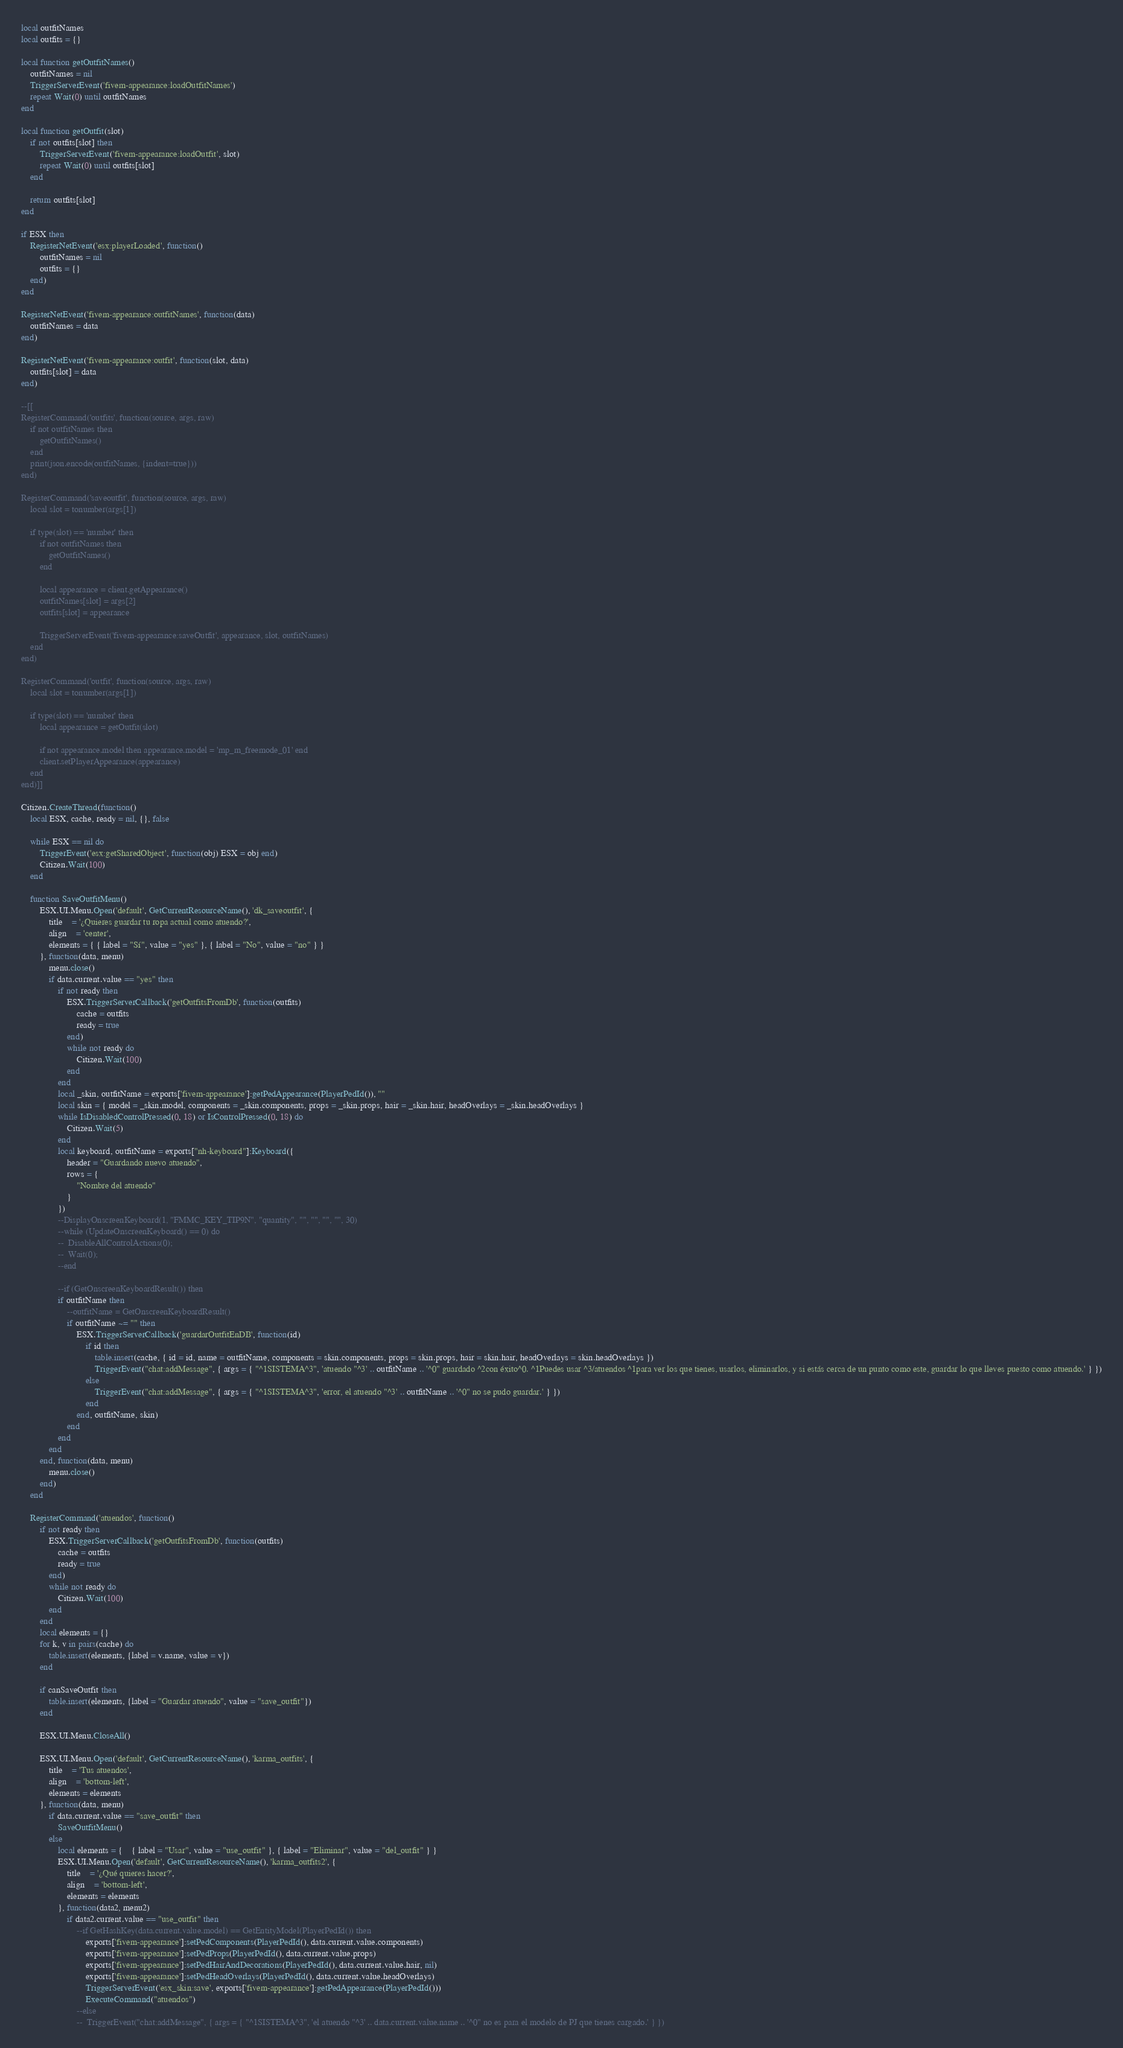<code> <loc_0><loc_0><loc_500><loc_500><_Lua_>
local outfitNames
local outfits = {}

local function getOutfitNames()
	outfitNames = nil
	TriggerServerEvent('fivem-appearance:loadOutfitNames')
	repeat Wait(0) until outfitNames
end

local function getOutfit(slot)
	if not outfits[slot] then
		TriggerServerEvent('fivem-appearance:loadOutfit', slot)
		repeat Wait(0) until outfits[slot]
	end

	return outfits[slot]
end

if ESX then
	RegisterNetEvent('esx:playerLoaded', function()
		outfitNames = nil
		outfits = {}
	end)
end

RegisterNetEvent('fivem-appearance:outfitNames', function(data)
	outfitNames = data
end)

RegisterNetEvent('fivem-appearance:outfit', function(slot, data)
	outfits[slot] = data
end)

--[[
RegisterCommand('outfits', function(source, args, raw)
	if not outfitNames then
		getOutfitNames()
	end
	print(json.encode(outfitNames, {indent=true}))
end)

RegisterCommand('saveoutfit', function(source, args, raw)
	local slot = tonumber(args[1])

	if type(slot) == 'number' then
		if not outfitNames then
			getOutfitNames()
		end

		local appearance = client.getAppearance()
		outfitNames[slot] = args[2]
		outfits[slot] = appearance

		TriggerServerEvent('fivem-appearance:saveOutfit', appearance, slot, outfitNames)
	end
end)

RegisterCommand('outfit', function(source, args, raw)
	local slot = tonumber(args[1])

	if type(slot) == 'number' then
		local appearance = getOutfit(slot)

		if not appearance.model then appearance.model = 'mp_m_freemode_01' end
		client.setPlayerAppearance(appearance)
	end
end)]]

Citizen.CreateThread(function()
	local ESX, cache, ready = nil, {}, false

    while ESX == nil do
        TriggerEvent('esx:getSharedObject', function(obj) ESX = obj end)
        Citizen.Wait(100)
    end

	function SaveOutfitMenu()
		ESX.UI.Menu.Open('default', GetCurrentResourceName(), 'dk_saveoutfit', {
			title    = '¿Quieres guardar tu ropa actual como atuendo?',
			align    = 'center',
			elements = { { label = "Sí", value = "yes" }, { label = "No", value = "no" } }
		}, function(data, menu)
			menu.close()
			if data.current.value == "yes" then
				if not ready then
					ESX.TriggerServerCallback('getOutfitsFromDb', function(outfits)
						cache = outfits
						ready = true
					end)
					while not ready do
						Citizen.Wait(100)
					end
				end
				local _skin, outfitName = exports['fivem-appearance']:getPedAppearance(PlayerPedId()), ""
				local skin = { model = _skin.model, components = _skin.components, props = _skin.props, hair = _skin.hair, headOverlays = _skin.headOverlays }
				while IsDisabledControlPressed(0, 18) or IsControlPressed(0, 18) do
					Citizen.Wait(5)
				end
				local keyboard, outfitName = exports["nh-keyboard"]:Keyboard({
					header = "Guardando nuevo atuendo",
					rows = {
						"Nombre del atuendo"
					}
				})
				--DisplayOnscreenKeyboard(1, "FMMC_KEY_TIP9N", "quantity", "", "", "", "", 30)
				--while (UpdateOnscreenKeyboard() == 0) do
				--	DisableAllControlActions(0);
				--	Wait(0);
				--end
			
				--if (GetOnscreenKeyboardResult()) then
				if outfitName then
					--outfitName = GetOnscreenKeyboardResult()
					if outfitName ~= "" then
						ESX.TriggerServerCallback('guardarOutfitEnDB', function(id)
							if id then
								table.insert(cache, { id = id, name = outfitName, components = skin.components, props = skin.props, hair = skin.hair, headOverlays = skin.headOverlays })
								TriggerEvent("chat:addMessage", { args = { "^1SISTEMA^3", 'atuendo "^3' .. outfitName .. '^0" guardado ^2con éxito^0. ^1Puedes usar ^3/atuendos ^1para ver los que tienes, usarlos, eliminarlos, y si estás cerca de un punto como este, guardar lo que lleves puesto como atuendo.' } })
							else
								TriggerEvent("chat:addMessage", { args = { "^1SISTEMA^3", 'error, el atuendo "^3' .. outfitName .. '^0" no se pudo guardar.' } })
							end
						end, outfitName, skin)
					end
				end
			end
		end, function(data, menu)
			menu.close()
		end)
	end

	RegisterCommand('atuendos', function()
		if not ready then
			ESX.TriggerServerCallback('getOutfitsFromDb', function(outfits)
				cache = outfits
				ready = true
			end)
			while not ready do
				Citizen.Wait(100)
			end
		end
		local elements = {}
		for k, v in pairs(cache) do
			table.insert(elements, {label = v.name, value = v})
		end
	
		if canSaveOutfit then
			table.insert(elements, {label = "Guardar atuendo", value = "save_outfit"})
		end
	
		ESX.UI.Menu.CloseAll()
	
		ESX.UI.Menu.Open('default', GetCurrentResourceName(), 'karma_outfits', {
			title    = 'Tus atuendos',
			align    = 'bottom-left',
			elements = elements
		}, function(data, menu)
			if data.current.value == "save_outfit" then
				SaveOutfitMenu()
			else
				local elements = {	{ label = "Usar", value = "use_outfit" }, { label = "Eliminar", value = "del_outfit" } }
				ESX.UI.Menu.Open('default', GetCurrentResourceName(), 'karma_outfits2', {
					title    = '¿Qué quieres hacer?',
					align    = 'bottom-left',
					elements = elements
				}, function(data2, menu2)
					if data2.current.value == "use_outfit" then
						--if GetHashKey(data.current.value.model) == GetEntityModel(PlayerPedId()) then
							exports['fivem-appearance']:setPedComponents(PlayerPedId(), data.current.value.components)
							exports['fivem-appearance']:setPedProps(PlayerPedId(), data.current.value.props)
							exports['fivem-appearance']:setPedHairAndDecorations(PlayerPedId(), data.current.value.hair, nil)
							exports['fivem-appearance']:setPedHeadOverlays(PlayerPedId(), data.current.value.headOverlays)
							TriggerServerEvent('esx_skin:save', exports['fivem-appearance']:getPedAppearance(PlayerPedId()))
							ExecuteCommand("atuendos")
						--else
						--	TriggerEvent("chat:addMessage", { args = { "^1SISTEMA^3", 'el atuendo "^3' .. data.current.value.name .. '^0" no es para el modelo de PJ que tienes cargado.' } })</code> 